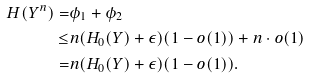<formula> <loc_0><loc_0><loc_500><loc_500>H ( Y ^ { n } ) = & \phi _ { 1 } + \phi _ { 2 } \\ \leq & n ( H _ { 0 } ( Y ) + \epsilon ) ( 1 - o ( 1 ) ) + n \cdot o ( 1 ) \\ = & n ( H _ { 0 } ( Y ) + \epsilon ) ( 1 - o ( 1 ) ) .</formula> 